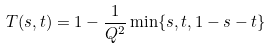Convert formula to latex. <formula><loc_0><loc_0><loc_500><loc_500>T ( s , t ) = 1 - \frac { 1 } { Q ^ { 2 } } \min \{ s , t , 1 - s - t \}</formula> 